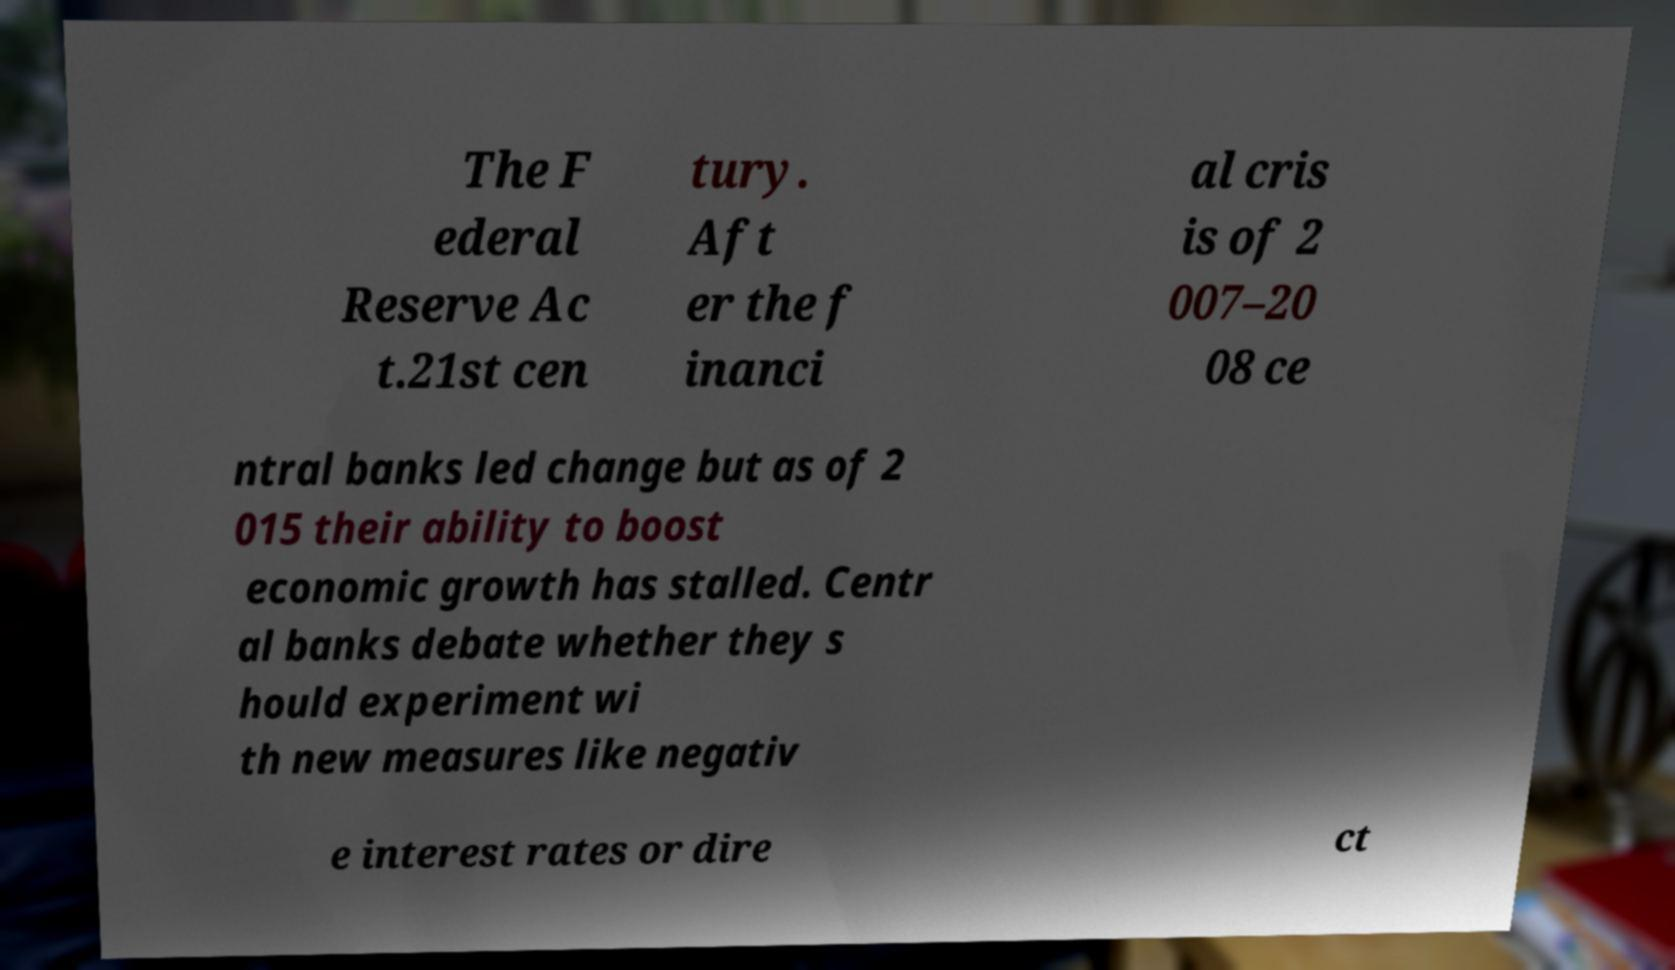I need the written content from this picture converted into text. Can you do that? The F ederal Reserve Ac t.21st cen tury. Aft er the f inanci al cris is of 2 007–20 08 ce ntral banks led change but as of 2 015 their ability to boost economic growth has stalled. Centr al banks debate whether they s hould experiment wi th new measures like negativ e interest rates or dire ct 